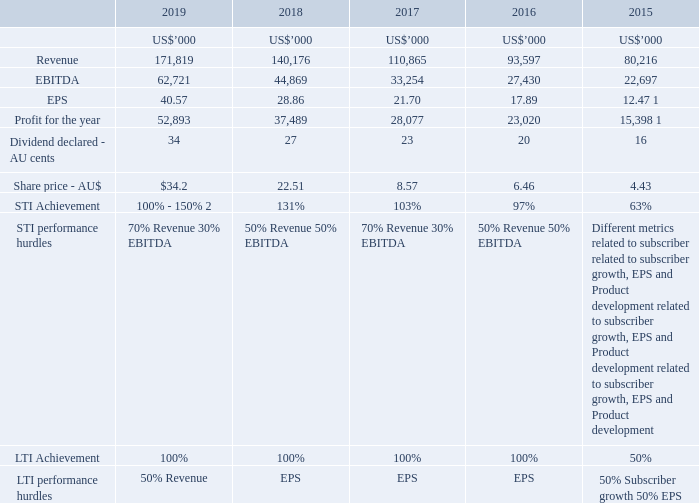4. Link between Group performance and remuneration outcomes
The Altium Remuneration Framework is designed to align key employee remuneration to shareholder returns (in the form of capital appreciation and dividends). The table below shows the Group performance on key financial results and performance metrics over the last five years.
Altium’s remuneration strategy has evolved over the past seven years and we believe that it is linked intrinsically to the success of the Group. Strong payout results for STI and LTI have reflected the strong financial performance of the Group. In addition, STI and LTI hurdles have changed over time to better reflect what is most important for Group growth.
1 Normalised EPS and Profit for the year excludes deferred tax asset of US$77 million recognised on the transfer of core business assets to the USA.
2 The maximum STI payable based on the above performance hurdles is 100%, however based on achievement of individual personal goals, the overall achievement level may be modified up to 150% or down to 0%.
What are the LTI performance hurdles in 2019? 50% revenue, 50% eps. What is the share price  in 2019? $34.2. What are the STI performance hurdles in 2019? 70% revenue, 30% ebitda. What is the percentage change in the revenue from 2018 to 2019?
Answer scale should be: percent. (171,819-140,176)/140,176
Answer: 22.57. What is the percentage change in profits from 2018 to 2019?
Answer scale should be: percent. (52,893-37,489)/37,489
Answer: 41.09. What is the percentage change in EBITDA from 2017 to 2018?
Answer scale should be: percent. (44,869-33,254)/33,254
Answer: 34.93. 